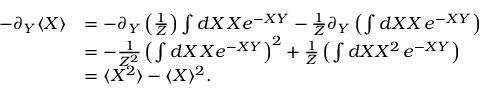<formula> <loc_0><loc_0><loc_500><loc_500>\begin{array} { r l } { - \partial _ { Y } \langle X \rangle } & { = - \partial _ { Y } \left ( \frac { 1 } { Z } \right ) \int d X \, X e ^ { - X Y } - \frac { 1 } { Z } \partial _ { Y } \left ( \int d X X \, e ^ { - X Y } \right ) } \\ & { = - \frac { 1 } { Z ^ { 2 } } \left ( \int d X \, X e ^ { - X Y } \right ) ^ { 2 } + \frac { 1 } { Z } \left ( \int d X X ^ { 2 } \, e ^ { - X Y } \right ) } \\ & { = \langle X ^ { 2 } \rangle - \langle X \rangle ^ { 2 } . } \end{array}</formula> 